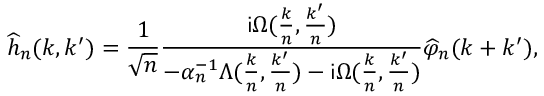Convert formula to latex. <formula><loc_0><loc_0><loc_500><loc_500>\widehat { h } _ { n } ( k , k ^ { \prime } ) = \frac { 1 } { \sqrt { n } } \frac { i \Omega ( \frac { k } { n } , \frac { k ^ { \prime } } { n } ) } { - \alpha _ { n } ^ { - 1 } \Lambda ( \frac { k } { n } , \frac { k ^ { \prime } } { n } ) - i \Omega ( \frac { k } { n } , \frac { k ^ { \prime } } { n } ) } \widehat { \varphi } _ { n } ( k + k ^ { \prime } ) ,</formula> 